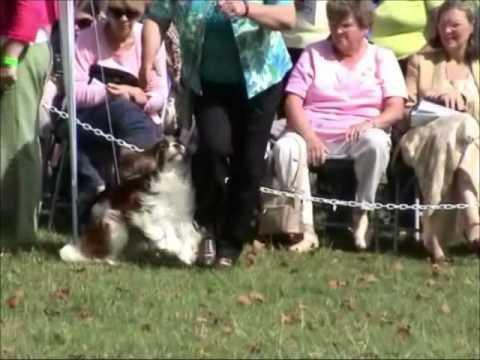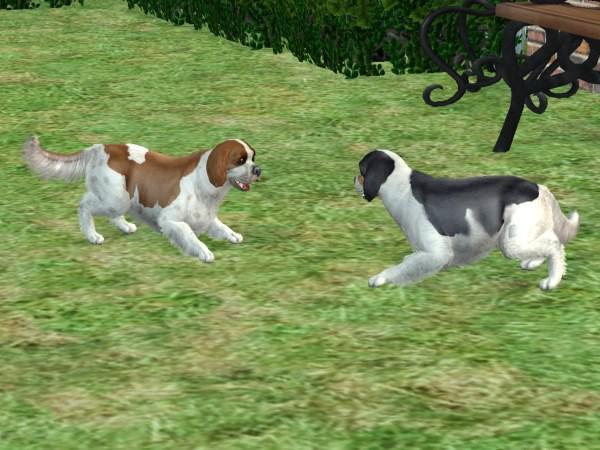The first image is the image on the left, the second image is the image on the right. Examine the images to the left and right. Is the description "At least one of the dogs is not standing on grass." accurate? Answer yes or no. No. 